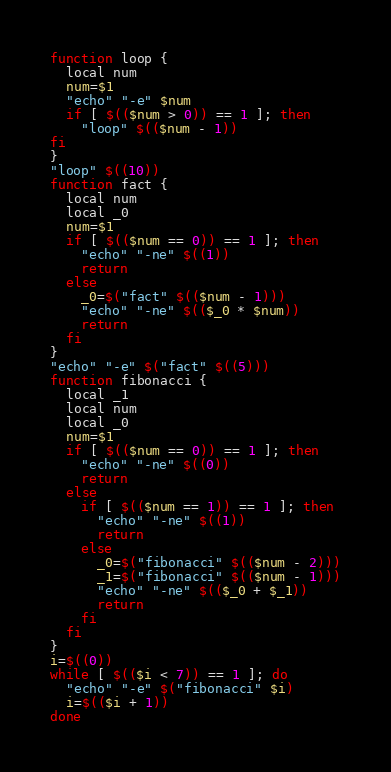Convert code to text. <code><loc_0><loc_0><loc_500><loc_500><_Bash_>function loop {
  local num
  num=$1
  "echo" "-e" $num
  if [ $(($num > 0)) == 1 ]; then
    "loop" $(($num - 1))  
fi
}
"loop" $((10))
function fact {
  local num
  local _0
  num=$1
  if [ $(($num == 0)) == 1 ]; then
    "echo" "-ne" $((1))
    return
  else
    _0=$("fact" $(($num - 1)))
    "echo" "-ne" $(($_0 * $num))
    return
  fi
}
"echo" "-e" $("fact" $((5)))
function fibonacci {
  local _1
  local num
  local _0
  num=$1
  if [ $(($num == 0)) == 1 ]; then
    "echo" "-ne" $((0))
    return
  else
    if [ $(($num == 1)) == 1 ]; then
      "echo" "-ne" $((1))
      return
    else
      _0=$("fibonacci" $(($num - 2)))
      _1=$("fibonacci" $(($num - 1)))
      "echo" "-ne" $(($_0 + $_1))
      return
    fi
  fi
}
i=$((0))
while [ $(($i < 7)) == 1 ]; do
  "echo" "-e" $("fibonacci" $i)
  i=$(($i + 1))
done
</code> 